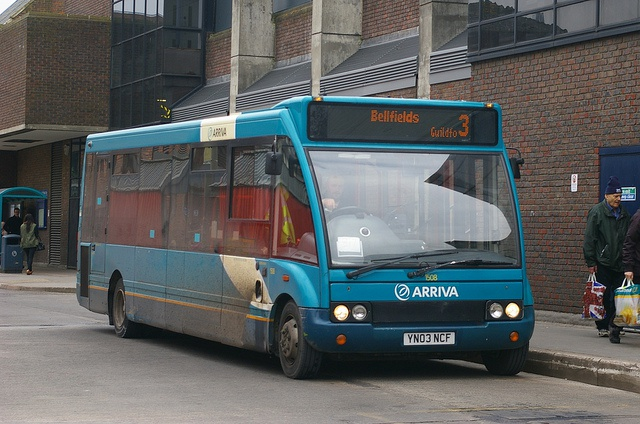Describe the objects in this image and their specific colors. I can see bus in white, gray, black, darkgray, and teal tones, people in white, black, gray, navy, and purple tones, people in white, darkgray, and lightgray tones, people in white, black, gray, and darkgreen tones, and people in white and black tones in this image. 